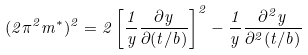Convert formula to latex. <formula><loc_0><loc_0><loc_500><loc_500>( 2 \pi ^ { 2 } m ^ { * } ) ^ { 2 } = 2 \left [ \frac { 1 } { y } \frac { \partial y } { \partial ( t / b ) } \right ] ^ { 2 } - \frac { 1 } { y } \frac { \partial ^ { 2 } y } { \partial ^ { 2 } ( t / b ) }</formula> 